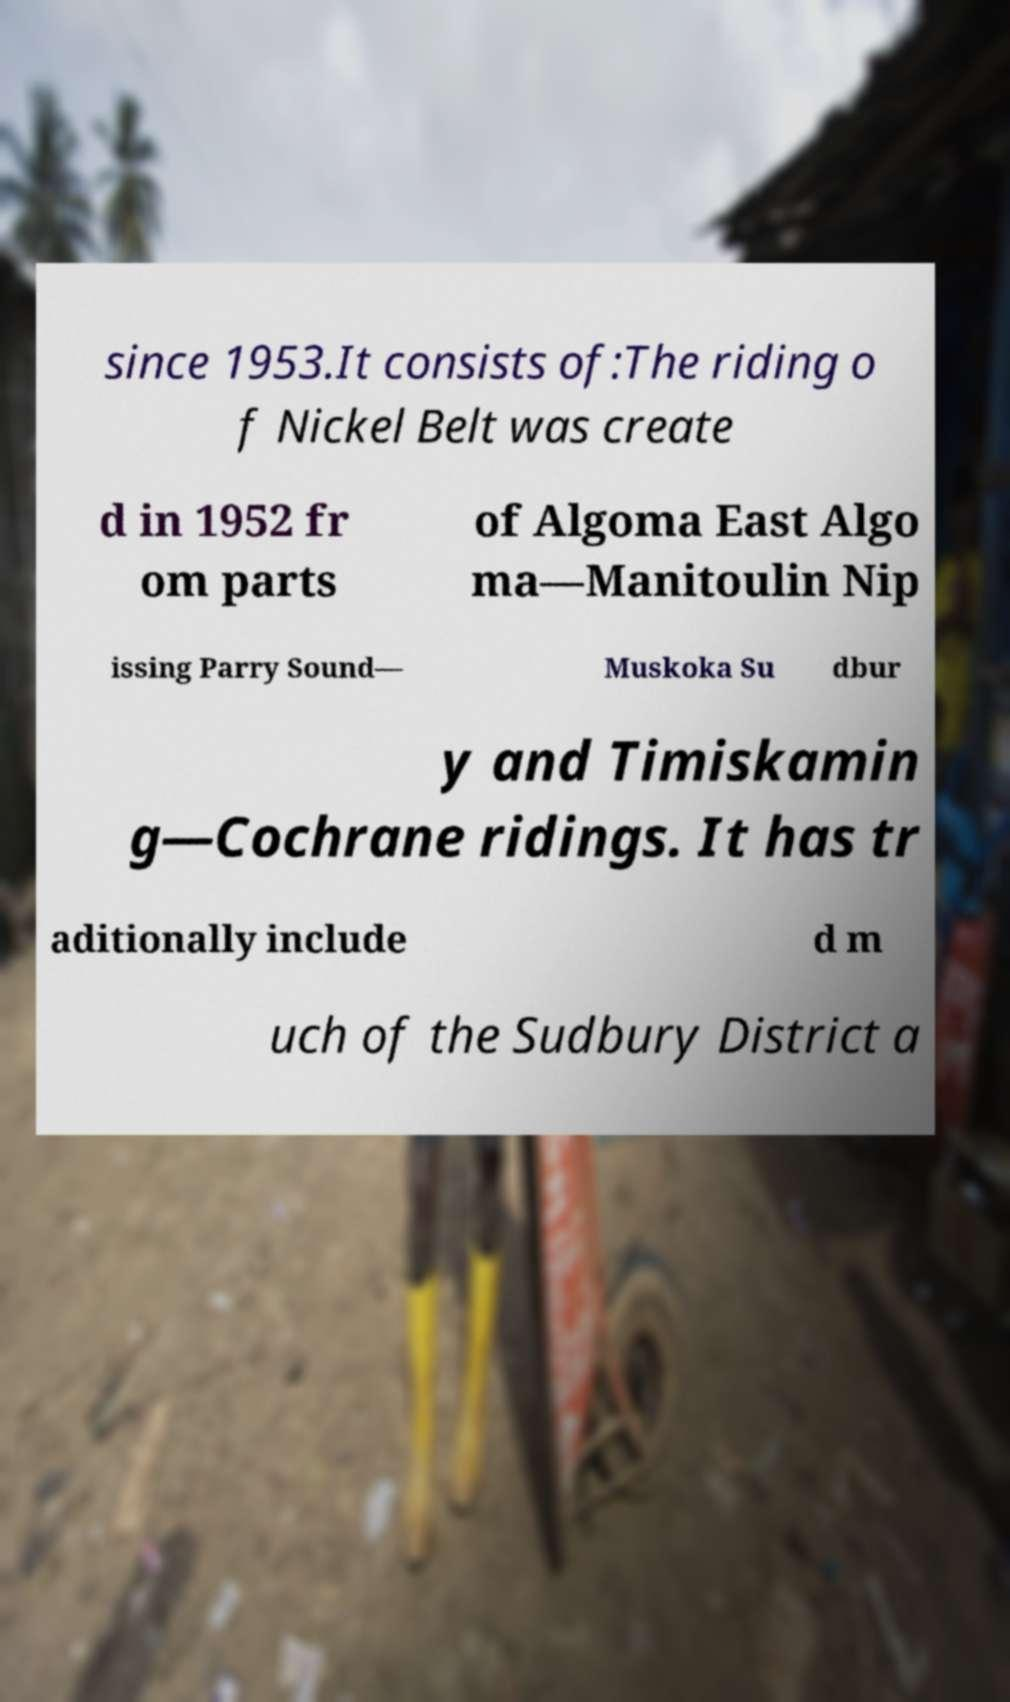Could you extract and type out the text from this image? since 1953.It consists of:The riding o f Nickel Belt was create d in 1952 fr om parts of Algoma East Algo ma—Manitoulin Nip issing Parry Sound— Muskoka Su dbur y and Timiskamin g—Cochrane ridings. It has tr aditionally include d m uch of the Sudbury District a 